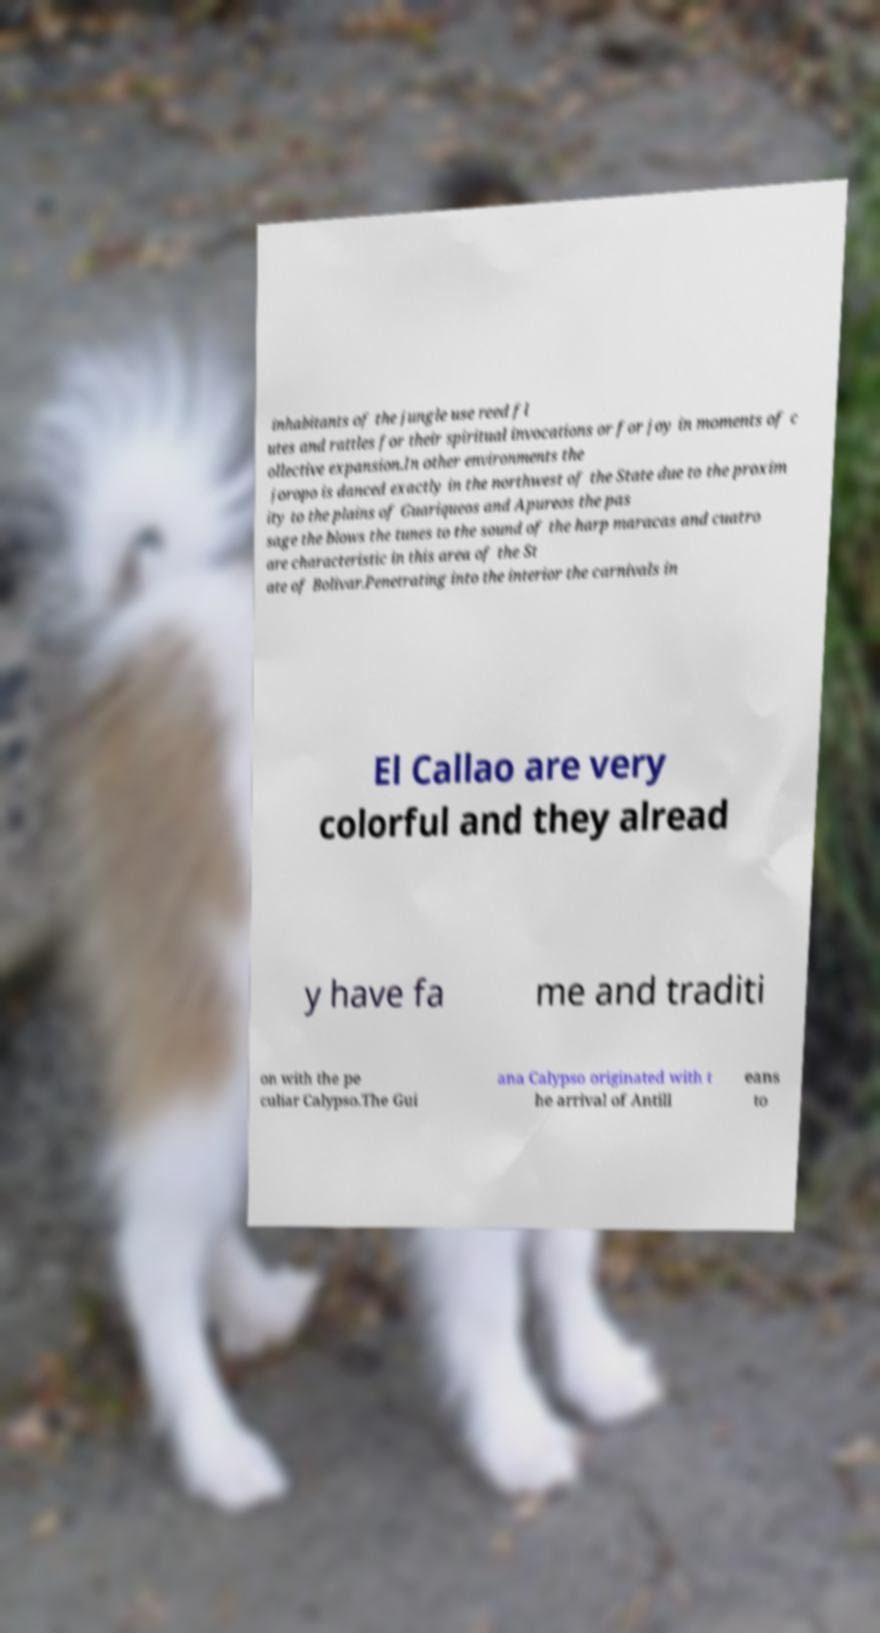Please read and relay the text visible in this image. What does it say? inhabitants of the jungle use reed fl utes and rattles for their spiritual invocations or for joy in moments of c ollective expansion.In other environments the joropo is danced exactly in the northwest of the State due to the proxim ity to the plains of Guariqueos and Apureos the pas sage the blows the tunes to the sound of the harp maracas and cuatro are characteristic in this area of the St ate of Bolivar.Penetrating into the interior the carnivals in El Callao are very colorful and they alread y have fa me and traditi on with the pe culiar Calypso.The Gui ana Calypso originated with t he arrival of Antill eans to 